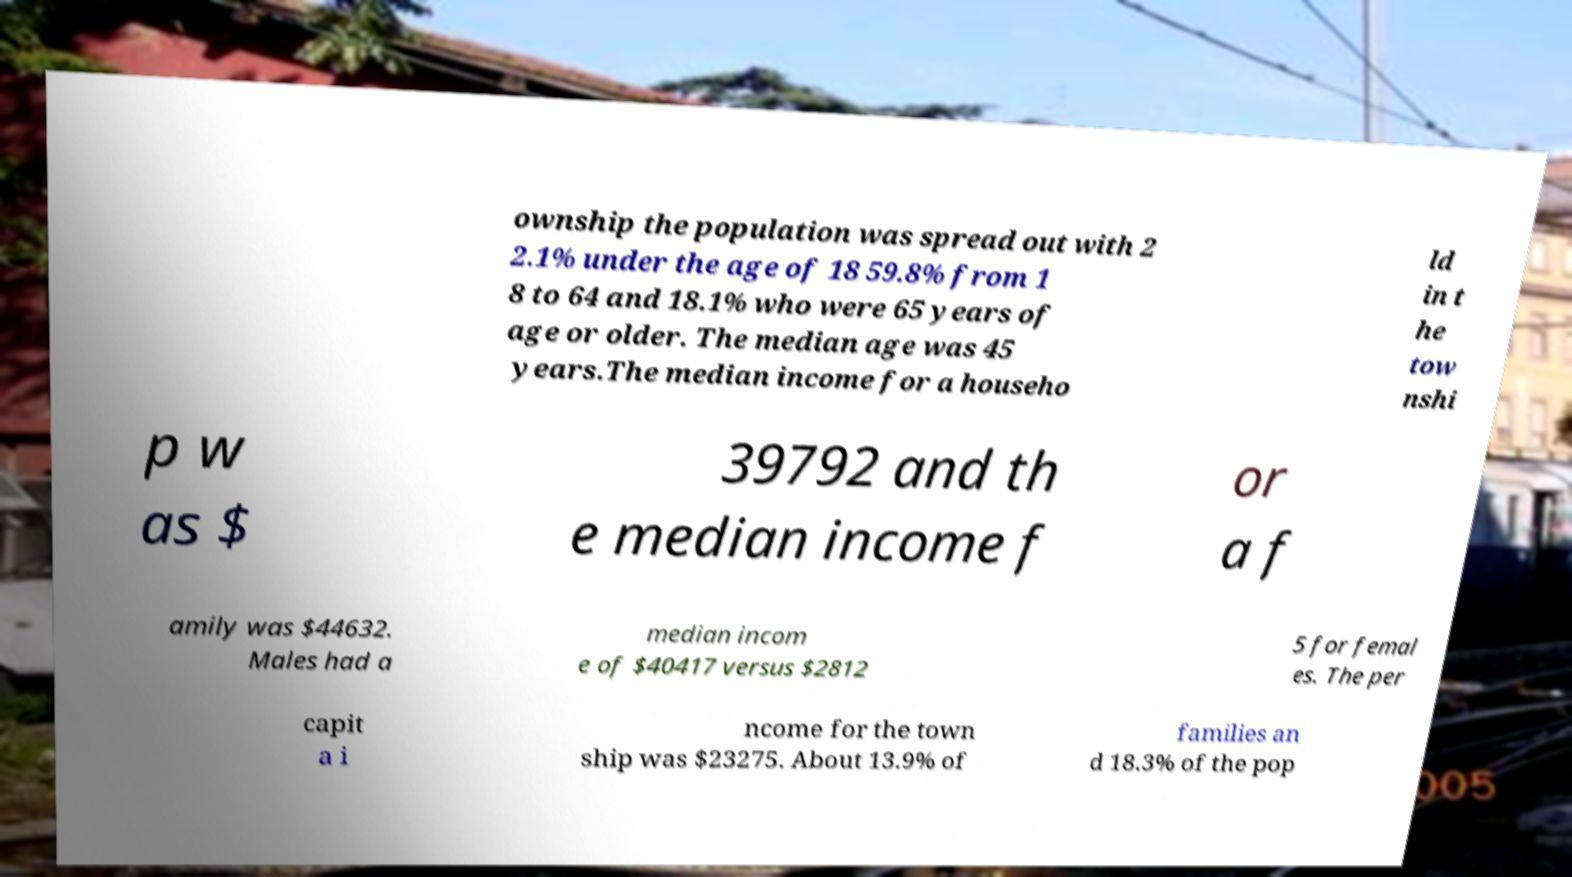Can you accurately transcribe the text from the provided image for me? ownship the population was spread out with 2 2.1% under the age of 18 59.8% from 1 8 to 64 and 18.1% who were 65 years of age or older. The median age was 45 years.The median income for a househo ld in t he tow nshi p w as $ 39792 and th e median income f or a f amily was $44632. Males had a median incom e of $40417 versus $2812 5 for femal es. The per capit a i ncome for the town ship was $23275. About 13.9% of families an d 18.3% of the pop 